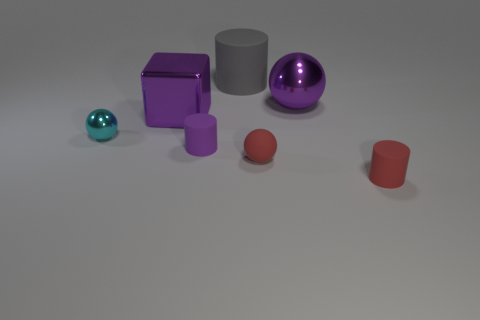What is the color of the large cube?
Keep it short and to the point. Purple. What number of purple metallic things have the same shape as the tiny purple matte thing?
Provide a short and direct response. 0. What color is the matte ball that is the same size as the purple matte object?
Provide a succinct answer. Red. Is there a tiny purple object?
Make the answer very short. Yes. There is a big thing that is left of the big rubber thing; what is its shape?
Offer a very short reply. Cube. What number of big purple metallic objects are to the right of the tiny purple matte thing and in front of the large purple metal ball?
Provide a short and direct response. 0. Is there a big gray cylinder made of the same material as the tiny purple thing?
Offer a very short reply. Yes. What size is the matte cylinder that is the same color as the shiny cube?
Make the answer very short. Small. What number of spheres are green metallic objects or tiny red things?
Keep it short and to the point. 1. What is the size of the cyan object?
Make the answer very short. Small. 